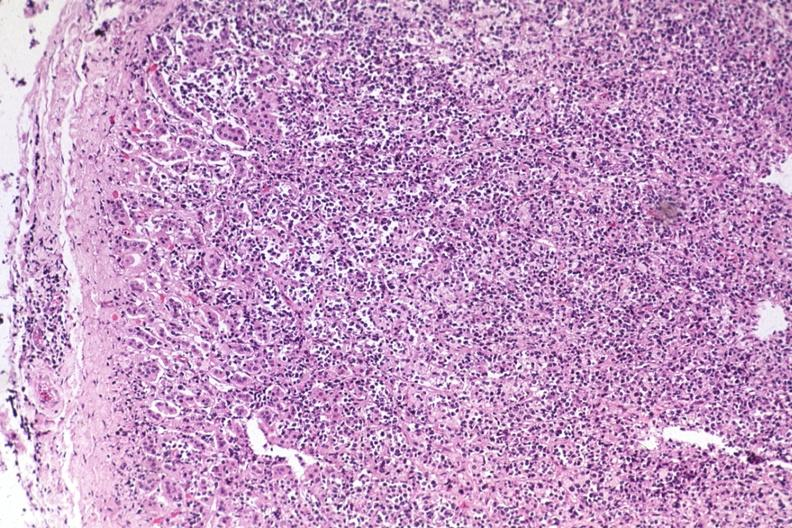what is present?
Answer the question using a single word or phrase. Endocrine 